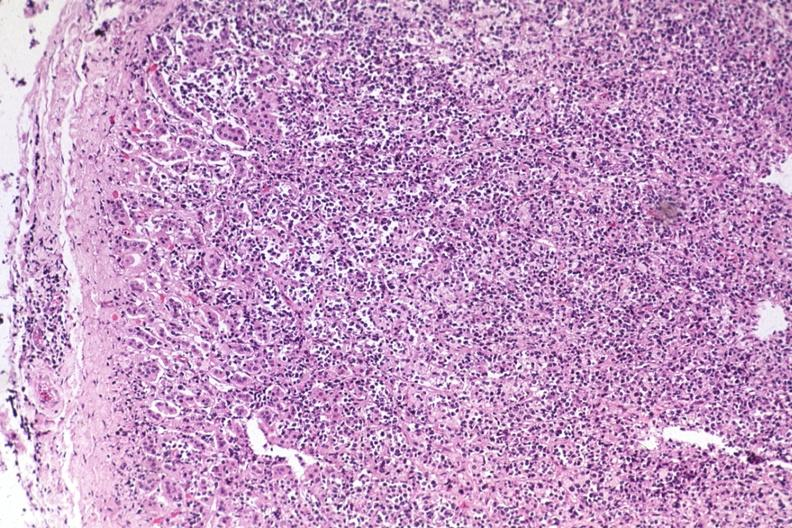what is present?
Answer the question using a single word or phrase. Endocrine 